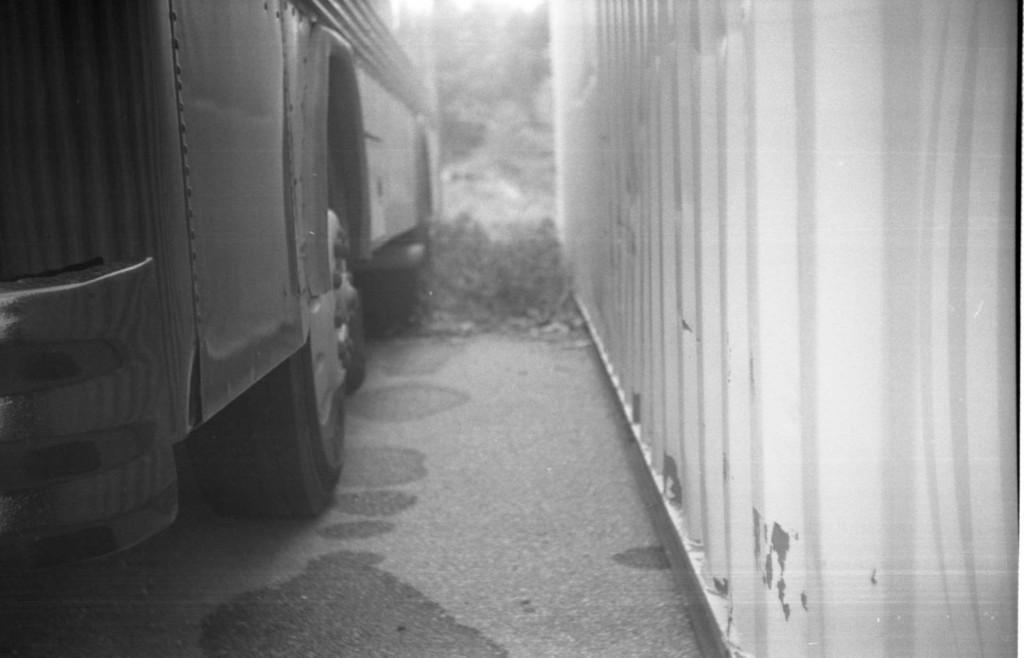Could you give a brief overview of what you see in this image? In this image I can see the black and white picture in which I can see a vehicle on the ground and a white colored object. In the background I can see few trees. 